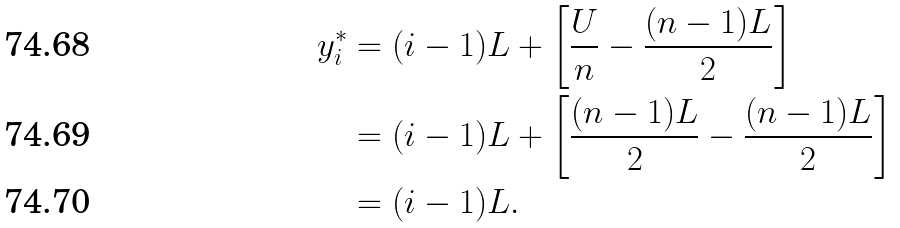<formula> <loc_0><loc_0><loc_500><loc_500>y ^ { * } _ { i } & = ( i - 1 ) L + \left [ \frac { U } { n } - \frac { ( n - 1 ) L } { 2 } \right ] \\ & = ( i - 1 ) L + \left [ \frac { ( n - 1 ) L } { 2 } - \frac { ( n - 1 ) L } { 2 } \right ] \\ & = ( i - 1 ) L .</formula> 